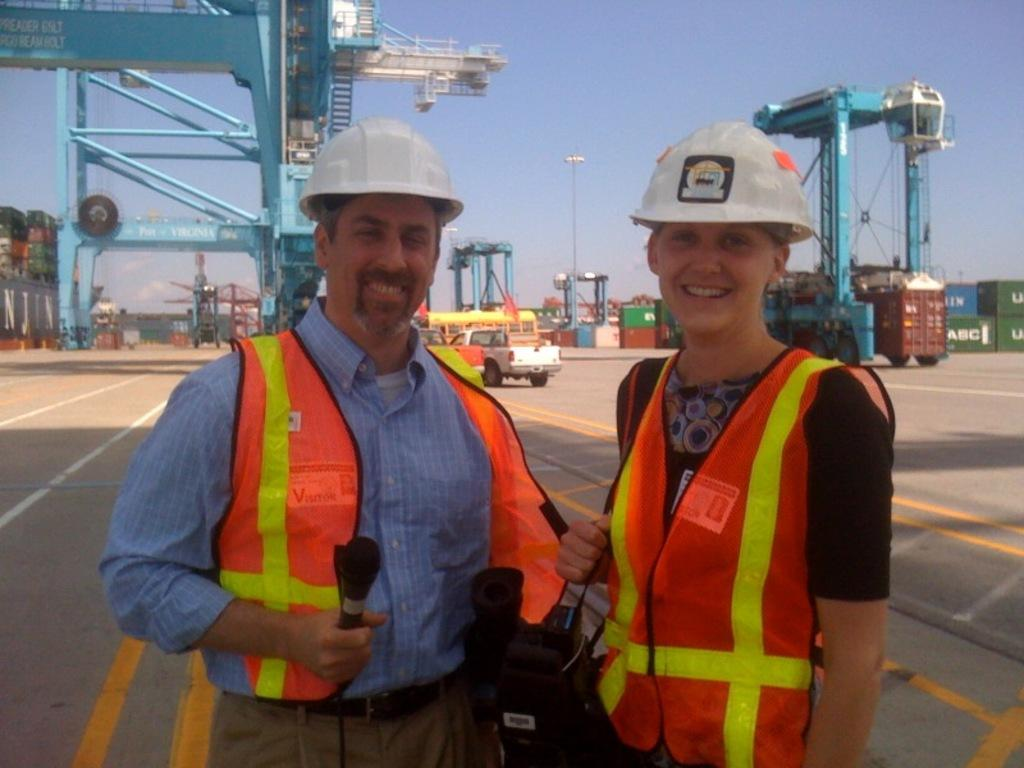How many people are in the image? There are two persons standing in the image. What are the persons wearing on their heads? The persons are wearing white helmets. What can be seen in the background of the image? There is a car in the background of the image. What is visible at the top of the image? The sky is visible at the top of the image. What type of zipper can be seen on the car in the image? There is no zipper present on the car in the image. Can you tell me how many pens are visible in the image? There are no pens visible in the image. 